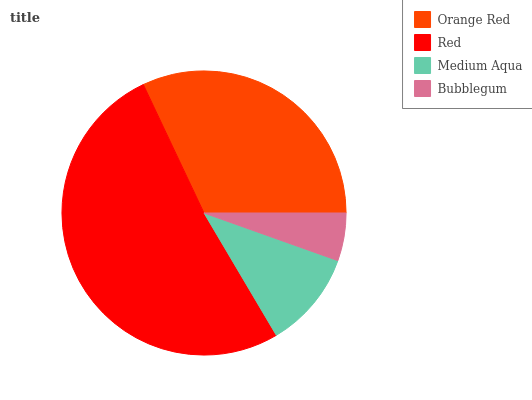Is Bubblegum the minimum?
Answer yes or no. Yes. Is Red the maximum?
Answer yes or no. Yes. Is Medium Aqua the minimum?
Answer yes or no. No. Is Medium Aqua the maximum?
Answer yes or no. No. Is Red greater than Medium Aqua?
Answer yes or no. Yes. Is Medium Aqua less than Red?
Answer yes or no. Yes. Is Medium Aqua greater than Red?
Answer yes or no. No. Is Red less than Medium Aqua?
Answer yes or no. No. Is Orange Red the high median?
Answer yes or no. Yes. Is Medium Aqua the low median?
Answer yes or no. Yes. Is Medium Aqua the high median?
Answer yes or no. No. Is Bubblegum the low median?
Answer yes or no. No. 